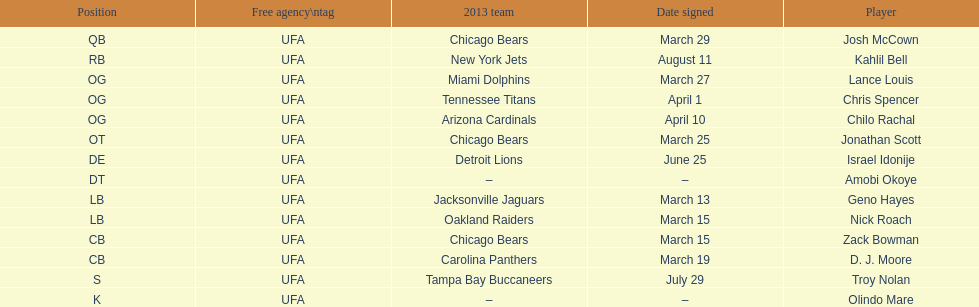How many players were signed in march? 7. 